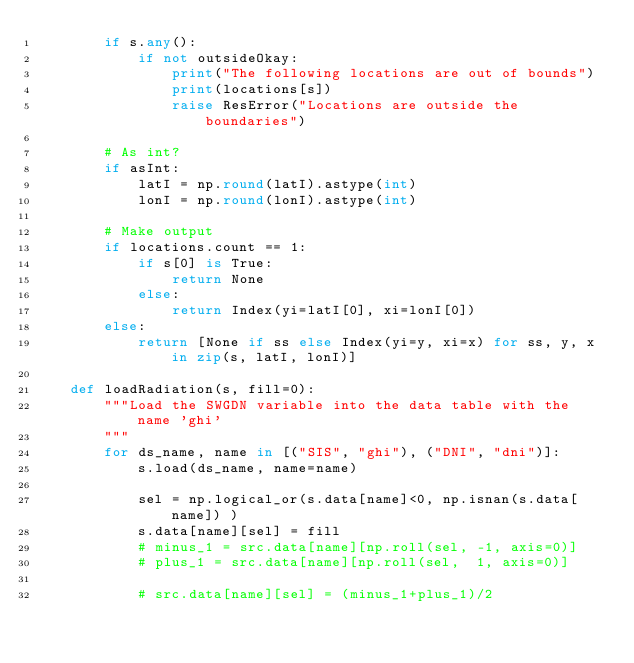Convert code to text. <code><loc_0><loc_0><loc_500><loc_500><_Python_>        if s.any():
            if not outsideOkay:
                print("The following locations are out of bounds")
                print(locations[s])
                raise ResError("Locations are outside the boundaries")

        # As int?
        if asInt:
            latI = np.round(latI).astype(int)
            lonI = np.round(lonI).astype(int)

        # Make output
        if locations.count == 1:
            if s[0] is True:
                return None
            else:
                return Index(yi=latI[0], xi=lonI[0])
        else:
            return [None if ss else Index(yi=y, xi=x) for ss, y, x in zip(s, latI, lonI)]

    def loadRadiation(s, fill=0):
        """Load the SWGDN variable into the data table with the name 'ghi'
        """
        for ds_name, name in [("SIS", "ghi"), ("DNI", "dni")]:
            s.load(ds_name, name=name)
            
            sel = np.logical_or(s.data[name]<0, np.isnan(s.data[name]) ) 
            s.data[name][sel] = fill
            # minus_1 = src.data[name][np.roll(sel, -1, axis=0)]
            # plus_1 = src.data[name][np.roll(sel,  1, axis=0)]
            
            # src.data[name][sel] = (minus_1+plus_1)/2

</code> 